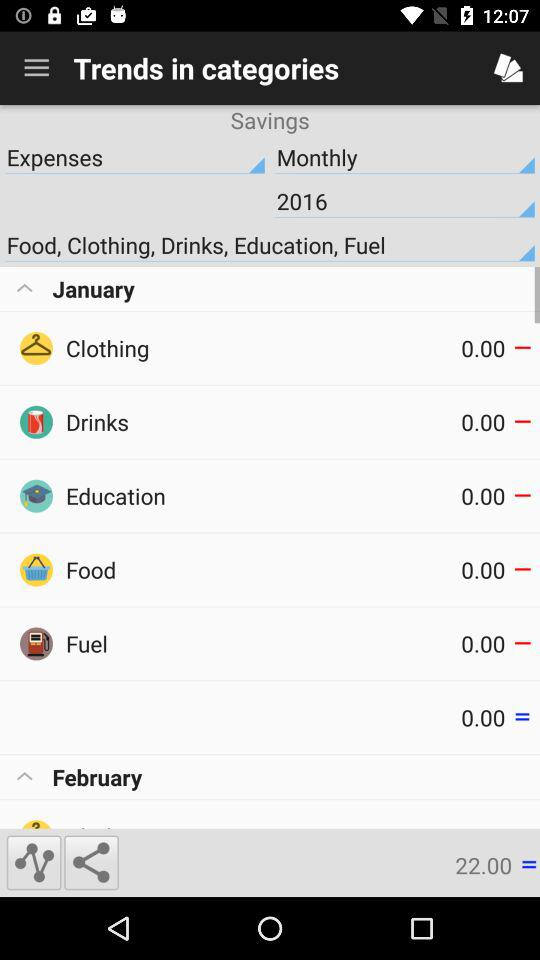What year is mentioned? The mentioned year is 2016. 